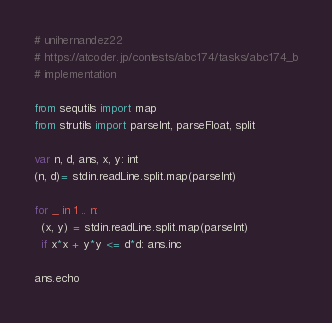Convert code to text. <code><loc_0><loc_0><loc_500><loc_500><_Nim_># unihernandez22
# https://atcoder.jp/contests/abc174/tasks/abc174_b
# implementation

from sequtils import map
from strutils import parseInt, parseFloat, split

var n, d, ans, x, y: int
(n, d)= stdin.readLine.split.map(parseInt)

for _ in 1 .. n:
  (x, y) = stdin.readLine.split.map(parseInt)
  if x*x + y*y <= d*d: ans.inc

ans.echo
</code> 